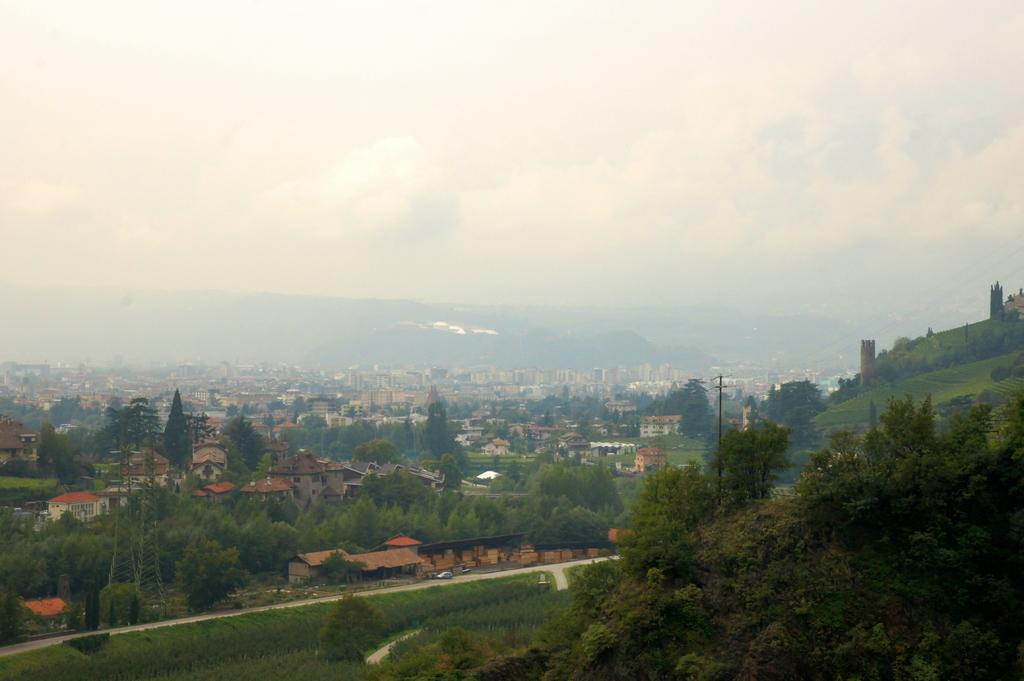What type of structures can be seen in the image? There are many buildings in the image. What other natural elements are present in the image? There are trees in the image. What can be seen in the distance in the background of the image? Hills and the sky are visible in the background of the image. What object is present in the image that is typically used for displaying signs or advertisements? There is a pole in the image. What type of pathway is visible in the image? There is a road in the image. What mode of transportation can be seen on the road? There is a car on the road. Can you hear the sound of the car's engine in the image? The image is a still picture, so there is no sound or hearing involved. Is there a chessboard visible on one of the hills in the image? There is no chessboard present in the image; it features buildings, trees, hills, the sky, a pole, a road, and a car. 